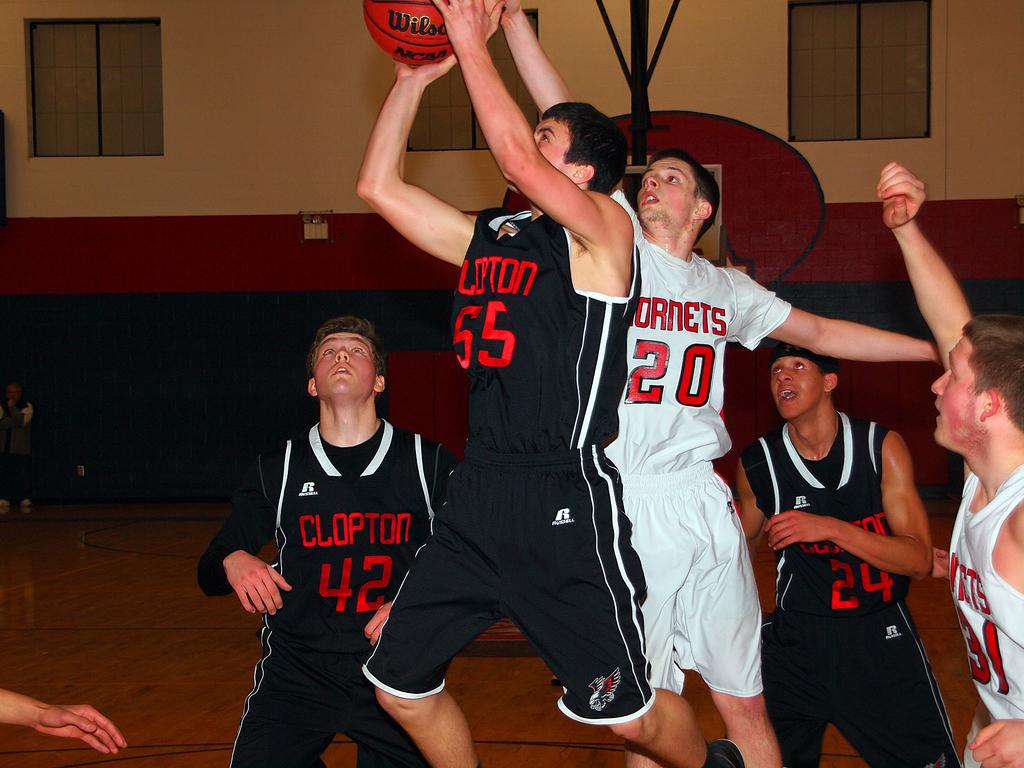<image>
Offer a succinct explanation of the picture presented. A basketball player is wearing the number 55 on his jersey. 